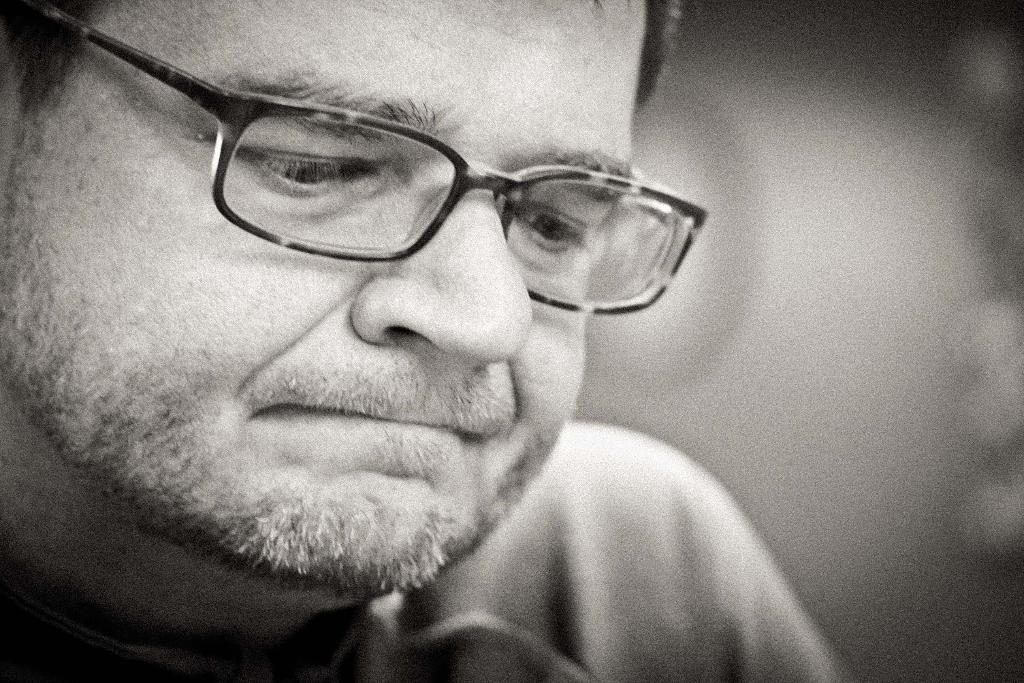What is the color scheme of the image? The image is black and white. Can you describe the person on the left side of the image? The person is on the left side of the image and is wearing spectacles. What is the condition of the right side of the image? The right side of the image is blurry. What type of brush can be seen in the person's hand in the image? There is no brush visible in the person's hand in the image. Can you describe the street where the person is standing in the image? There is no street visible in the image; it is a black and white photograph with a person wearing spectacles on the left side and a blurry right side. 